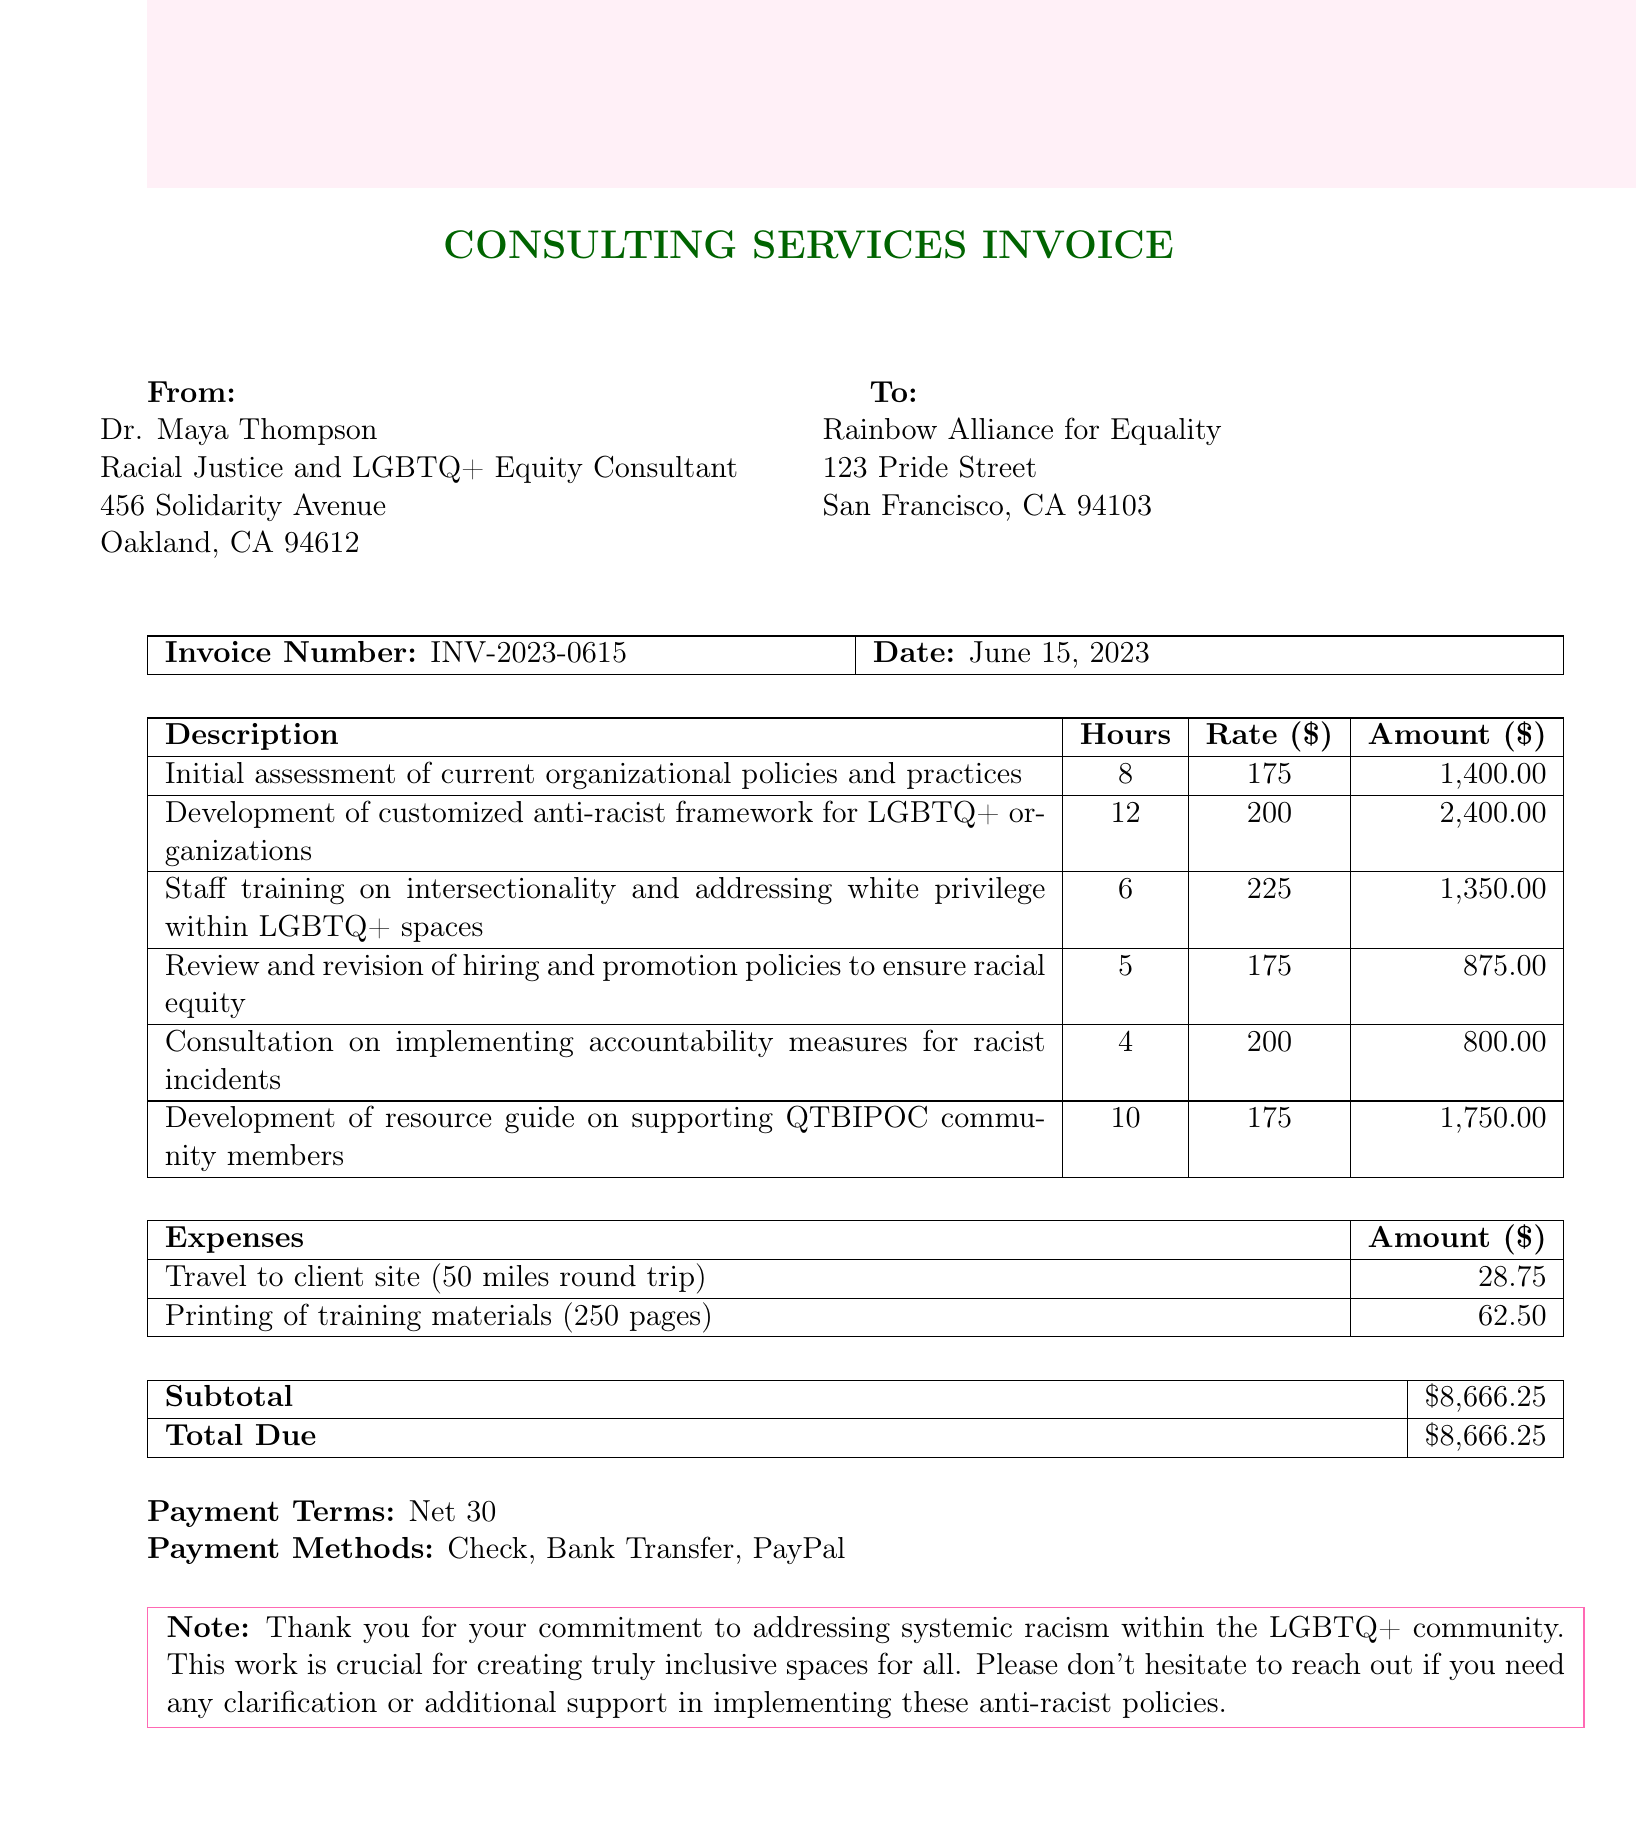What is the invoice number? The invoice number is explicitly listed in the document.
Answer: INV-2023-0615 Who is the consultant? The name of the consultant is provided in the document under the consultant section.
Answer: Dr. Maya Thompson What is the total due amount? The total due is calculated from the subtotal, including all services and expenses listed.
Answer: $8,666.25 How many hours were spent on staff training? The document specifies the hours allocated to staff training.
Answer: 6 What is the expense for printing training materials? The cost for printing training materials is detailed under expenses in the invoice.
Answer: 62.50 What payment terms are specified? The terms of payment are stated directly in the document.
Answer: Net 30 How many hours were dedicated to developing an anti-racist framework? The document states the hours for this specific service within the services section.
Answer: 12 What is the consultant's title? The title of the consultant is listed immediately following the consultant's name.
Answer: Racial Justice and LGBTQ+ Equity Consultant What method of payment is NOT listed? The document includes specific payment methods; an omitted method indicates what is not listed.
Answer: Credit Card 